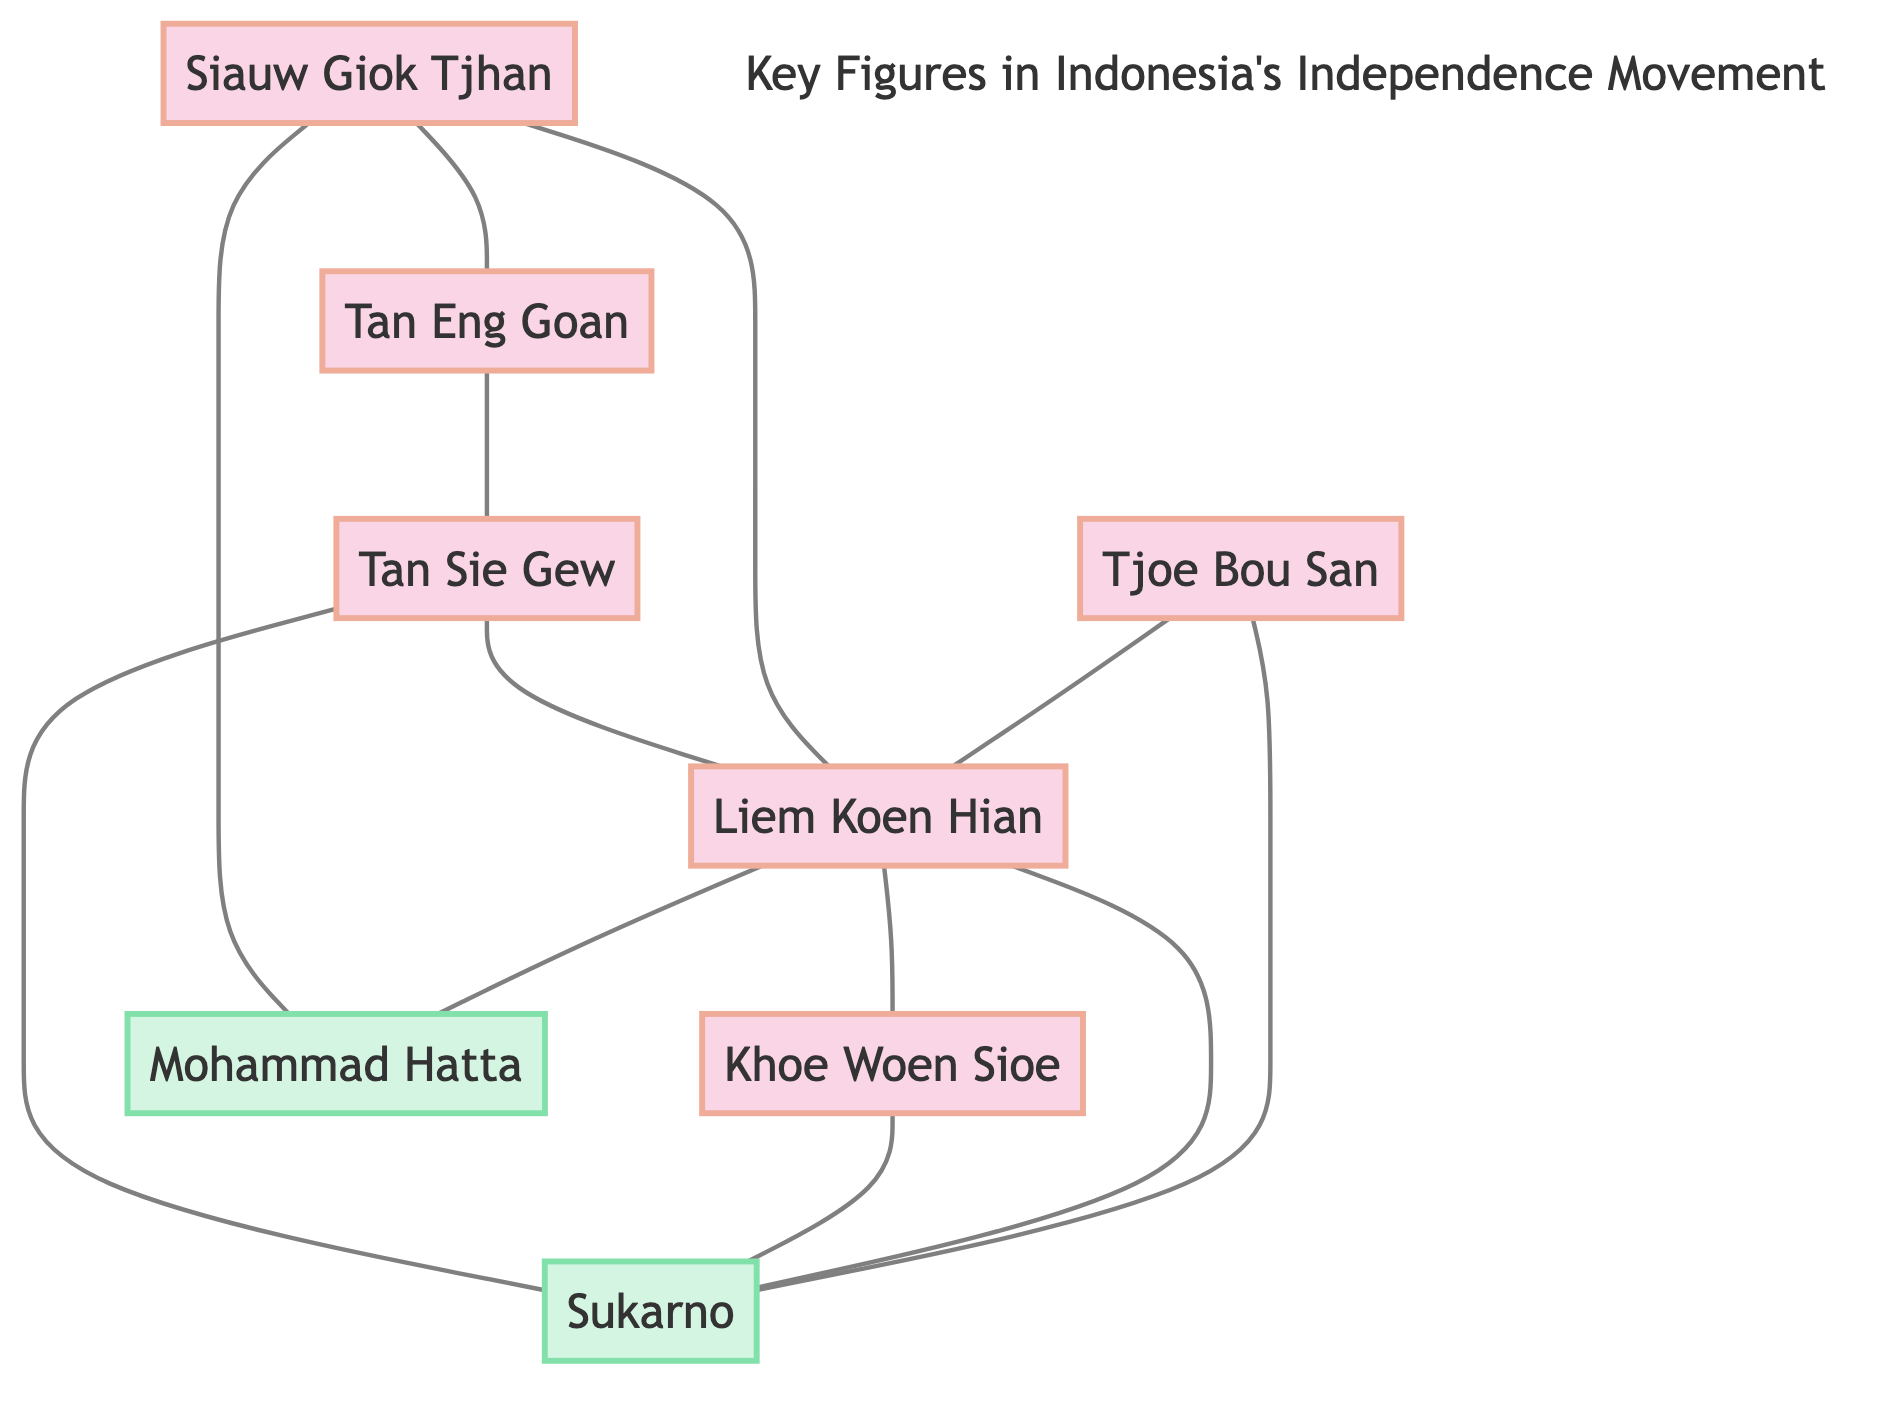What are the total number of nodes in the diagram? The diagram includes nodes that represent key figures of the Chinese Indonesian community and Indonesian leaders. By counting the entries in the nodes, we find there are a total of 8 distinct nodes: Tjoe Bou San, Liem Koen Hian, Khoe Woen Sioe, Siauw Giok Tjhan, Tan Eng Goan, Tan Sie Gew, Sukarno, and Mohammad Hatta.
Answer: 8 Which two figures are directly connected to Liem Koen Hian? By examining the edges (connections) from the Liem Koen Hian node, we can see it is connected to Sukarno, Mohammad Hatta, and Khoe Woen Sioe. The question asks for two specific figures, so we can choose any two of these three connected figures.
Answer: Sukarno, Mohammad Hatta Who is the only person connected to both Siauw Giok Tjhan and Tan Eng Goan? Looking at the diagram, we notice from the edges that Siauw Giok Tjhan connects to Liem Koen Hian and Tan Eng Goan. Subsequently, Tan Eng Goan connects to Tan Sie Gew. Thus, Siauw Giok Tjhan and Tan Eng Goan have a common connection, which is Liem Koen Hian.
Answer: Liem Koen Hian How many connections does Tan Sie Gew have? To find the number of connections for Tan Sie Gew, we look at the edges connected to the Tan Sie Gew node. It connects to both Liem Koen Hian and Sukarno. Thus, counting these connections gives us two.
Answer: 2 Which figures are connected to Sukarno? Analyzing the edges in the diagram, Sukarno has edges connecting him to Tjoe Bou San, Liem Koen Hian, Khoe Woen Sioe, and Tan Sie Gew. This makes a total of four figures connected to Sukarno.
Answer: Tjoe Bou San, Liem Koen Hian, Khoe Woen Sioe, Tan Sie Gew What is the relationship between Khoe Woen Sioe and Liem Koen Hian? The diagram shows a direct edge connecting Khoe Woen Sioe to Liem Koen Hian, indicating that there is a relationship between them in the context of the independence movement.
Answer: Direct connection Which figure has the most connections in the diagram? By examining the number of edges connected to each figure in the diagram, we find that Liem Koen Hian has 5 connections: to Sukarno, Mohammad Hatta, Khoe Woen Sioe, Siauw Giok Tjhan, and Tan Sie Gew.
Answer: Liem Koen Hian 